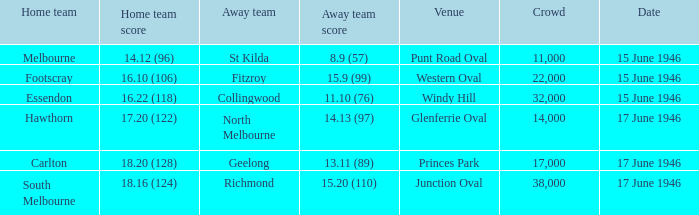When did a home team achieve a score of 16.10 (106)? 15 June 1946. 